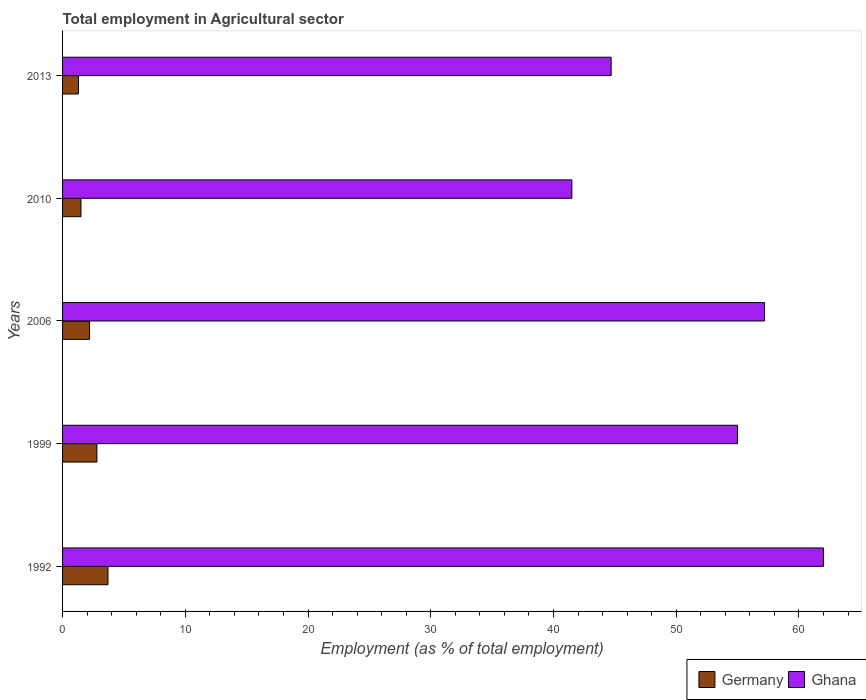How many different coloured bars are there?
Give a very brief answer. 2. Are the number of bars per tick equal to the number of legend labels?
Give a very brief answer. Yes. Are the number of bars on each tick of the Y-axis equal?
Keep it short and to the point. Yes. How many bars are there on the 2nd tick from the top?
Your response must be concise. 2. How many bars are there on the 1st tick from the bottom?
Provide a short and direct response. 2. What is the label of the 4th group of bars from the top?
Ensure brevity in your answer.  1999. What is the employment in agricultural sector in Ghana in 2006?
Offer a very short reply. 57.2. Across all years, what is the minimum employment in agricultural sector in Germany?
Offer a very short reply. 1.3. In which year was the employment in agricultural sector in Germany maximum?
Your answer should be very brief. 1992. What is the total employment in agricultural sector in Germany in the graph?
Your answer should be compact. 11.5. What is the difference between the employment in agricultural sector in Germany in 1999 and that in 2010?
Make the answer very short. 1.3. What is the difference between the employment in agricultural sector in Ghana in 2010 and the employment in agricultural sector in Germany in 1992?
Your answer should be very brief. 37.8. In the year 2010, what is the difference between the employment in agricultural sector in Germany and employment in agricultural sector in Ghana?
Your answer should be compact. -40. What is the ratio of the employment in agricultural sector in Ghana in 2006 to that in 2013?
Keep it short and to the point. 1.28. Is the employment in agricultural sector in Germany in 1992 less than that in 2013?
Provide a succinct answer. No. What is the difference between the highest and the second highest employment in agricultural sector in Germany?
Give a very brief answer. 0.9. What is the difference between the highest and the lowest employment in agricultural sector in Ghana?
Your answer should be very brief. 20.5. In how many years, is the employment in agricultural sector in Germany greater than the average employment in agricultural sector in Germany taken over all years?
Give a very brief answer. 2. What does the 1st bar from the bottom in 1999 represents?
Offer a terse response. Germany. How many bars are there?
Give a very brief answer. 10. How many years are there in the graph?
Offer a very short reply. 5. Are the values on the major ticks of X-axis written in scientific E-notation?
Your response must be concise. No. Does the graph contain any zero values?
Ensure brevity in your answer.  No. How are the legend labels stacked?
Offer a terse response. Horizontal. What is the title of the graph?
Your response must be concise. Total employment in Agricultural sector. What is the label or title of the X-axis?
Make the answer very short. Employment (as % of total employment). What is the label or title of the Y-axis?
Ensure brevity in your answer.  Years. What is the Employment (as % of total employment) in Germany in 1992?
Your response must be concise. 3.7. What is the Employment (as % of total employment) of Ghana in 1992?
Offer a terse response. 62. What is the Employment (as % of total employment) in Germany in 1999?
Your answer should be compact. 2.8. What is the Employment (as % of total employment) in Germany in 2006?
Your answer should be very brief. 2.2. What is the Employment (as % of total employment) in Ghana in 2006?
Make the answer very short. 57.2. What is the Employment (as % of total employment) of Ghana in 2010?
Your answer should be compact. 41.5. What is the Employment (as % of total employment) of Germany in 2013?
Your answer should be very brief. 1.3. What is the Employment (as % of total employment) of Ghana in 2013?
Ensure brevity in your answer.  44.7. Across all years, what is the maximum Employment (as % of total employment) in Germany?
Your response must be concise. 3.7. Across all years, what is the maximum Employment (as % of total employment) of Ghana?
Ensure brevity in your answer.  62. Across all years, what is the minimum Employment (as % of total employment) in Germany?
Keep it short and to the point. 1.3. Across all years, what is the minimum Employment (as % of total employment) of Ghana?
Provide a short and direct response. 41.5. What is the total Employment (as % of total employment) of Germany in the graph?
Offer a very short reply. 11.5. What is the total Employment (as % of total employment) in Ghana in the graph?
Provide a short and direct response. 260.4. What is the difference between the Employment (as % of total employment) in Ghana in 1992 and that in 2006?
Offer a very short reply. 4.8. What is the difference between the Employment (as % of total employment) of Germany in 1992 and that in 2010?
Your response must be concise. 2.2. What is the difference between the Employment (as % of total employment) in Ghana in 1992 and that in 2010?
Offer a terse response. 20.5. What is the difference between the Employment (as % of total employment) of Germany in 1999 and that in 2006?
Give a very brief answer. 0.6. What is the difference between the Employment (as % of total employment) in Germany in 1999 and that in 2010?
Provide a succinct answer. 1.3. What is the difference between the Employment (as % of total employment) in Ghana in 1999 and that in 2010?
Make the answer very short. 13.5. What is the difference between the Employment (as % of total employment) in Ghana in 1999 and that in 2013?
Give a very brief answer. 10.3. What is the difference between the Employment (as % of total employment) of Ghana in 2006 and that in 2010?
Offer a very short reply. 15.7. What is the difference between the Employment (as % of total employment) in Ghana in 2006 and that in 2013?
Offer a very short reply. 12.5. What is the difference between the Employment (as % of total employment) of Ghana in 2010 and that in 2013?
Give a very brief answer. -3.2. What is the difference between the Employment (as % of total employment) in Germany in 1992 and the Employment (as % of total employment) in Ghana in 1999?
Keep it short and to the point. -51.3. What is the difference between the Employment (as % of total employment) of Germany in 1992 and the Employment (as % of total employment) of Ghana in 2006?
Your answer should be compact. -53.5. What is the difference between the Employment (as % of total employment) of Germany in 1992 and the Employment (as % of total employment) of Ghana in 2010?
Give a very brief answer. -37.8. What is the difference between the Employment (as % of total employment) of Germany in 1992 and the Employment (as % of total employment) of Ghana in 2013?
Your response must be concise. -41. What is the difference between the Employment (as % of total employment) of Germany in 1999 and the Employment (as % of total employment) of Ghana in 2006?
Your answer should be compact. -54.4. What is the difference between the Employment (as % of total employment) of Germany in 1999 and the Employment (as % of total employment) of Ghana in 2010?
Provide a short and direct response. -38.7. What is the difference between the Employment (as % of total employment) in Germany in 1999 and the Employment (as % of total employment) in Ghana in 2013?
Keep it short and to the point. -41.9. What is the difference between the Employment (as % of total employment) in Germany in 2006 and the Employment (as % of total employment) in Ghana in 2010?
Give a very brief answer. -39.3. What is the difference between the Employment (as % of total employment) in Germany in 2006 and the Employment (as % of total employment) in Ghana in 2013?
Offer a terse response. -42.5. What is the difference between the Employment (as % of total employment) in Germany in 2010 and the Employment (as % of total employment) in Ghana in 2013?
Provide a succinct answer. -43.2. What is the average Employment (as % of total employment) in Ghana per year?
Make the answer very short. 52.08. In the year 1992, what is the difference between the Employment (as % of total employment) in Germany and Employment (as % of total employment) in Ghana?
Your response must be concise. -58.3. In the year 1999, what is the difference between the Employment (as % of total employment) of Germany and Employment (as % of total employment) of Ghana?
Offer a terse response. -52.2. In the year 2006, what is the difference between the Employment (as % of total employment) in Germany and Employment (as % of total employment) in Ghana?
Offer a very short reply. -55. In the year 2010, what is the difference between the Employment (as % of total employment) of Germany and Employment (as % of total employment) of Ghana?
Offer a terse response. -40. In the year 2013, what is the difference between the Employment (as % of total employment) in Germany and Employment (as % of total employment) in Ghana?
Keep it short and to the point. -43.4. What is the ratio of the Employment (as % of total employment) of Germany in 1992 to that in 1999?
Your answer should be very brief. 1.32. What is the ratio of the Employment (as % of total employment) of Ghana in 1992 to that in 1999?
Provide a succinct answer. 1.13. What is the ratio of the Employment (as % of total employment) in Germany in 1992 to that in 2006?
Your response must be concise. 1.68. What is the ratio of the Employment (as % of total employment) in Ghana in 1992 to that in 2006?
Offer a very short reply. 1.08. What is the ratio of the Employment (as % of total employment) of Germany in 1992 to that in 2010?
Offer a terse response. 2.47. What is the ratio of the Employment (as % of total employment) of Ghana in 1992 to that in 2010?
Keep it short and to the point. 1.49. What is the ratio of the Employment (as % of total employment) of Germany in 1992 to that in 2013?
Ensure brevity in your answer.  2.85. What is the ratio of the Employment (as % of total employment) in Ghana in 1992 to that in 2013?
Provide a succinct answer. 1.39. What is the ratio of the Employment (as % of total employment) in Germany in 1999 to that in 2006?
Give a very brief answer. 1.27. What is the ratio of the Employment (as % of total employment) in Ghana in 1999 to that in 2006?
Your answer should be compact. 0.96. What is the ratio of the Employment (as % of total employment) of Germany in 1999 to that in 2010?
Your response must be concise. 1.87. What is the ratio of the Employment (as % of total employment) of Ghana in 1999 to that in 2010?
Offer a terse response. 1.33. What is the ratio of the Employment (as % of total employment) of Germany in 1999 to that in 2013?
Your answer should be very brief. 2.15. What is the ratio of the Employment (as % of total employment) in Ghana in 1999 to that in 2013?
Your answer should be very brief. 1.23. What is the ratio of the Employment (as % of total employment) in Germany in 2006 to that in 2010?
Offer a terse response. 1.47. What is the ratio of the Employment (as % of total employment) of Ghana in 2006 to that in 2010?
Make the answer very short. 1.38. What is the ratio of the Employment (as % of total employment) of Germany in 2006 to that in 2013?
Offer a terse response. 1.69. What is the ratio of the Employment (as % of total employment) in Ghana in 2006 to that in 2013?
Your answer should be very brief. 1.28. What is the ratio of the Employment (as % of total employment) of Germany in 2010 to that in 2013?
Your answer should be very brief. 1.15. What is the ratio of the Employment (as % of total employment) of Ghana in 2010 to that in 2013?
Give a very brief answer. 0.93. What is the difference between the highest and the second highest Employment (as % of total employment) in Germany?
Your answer should be very brief. 0.9. 